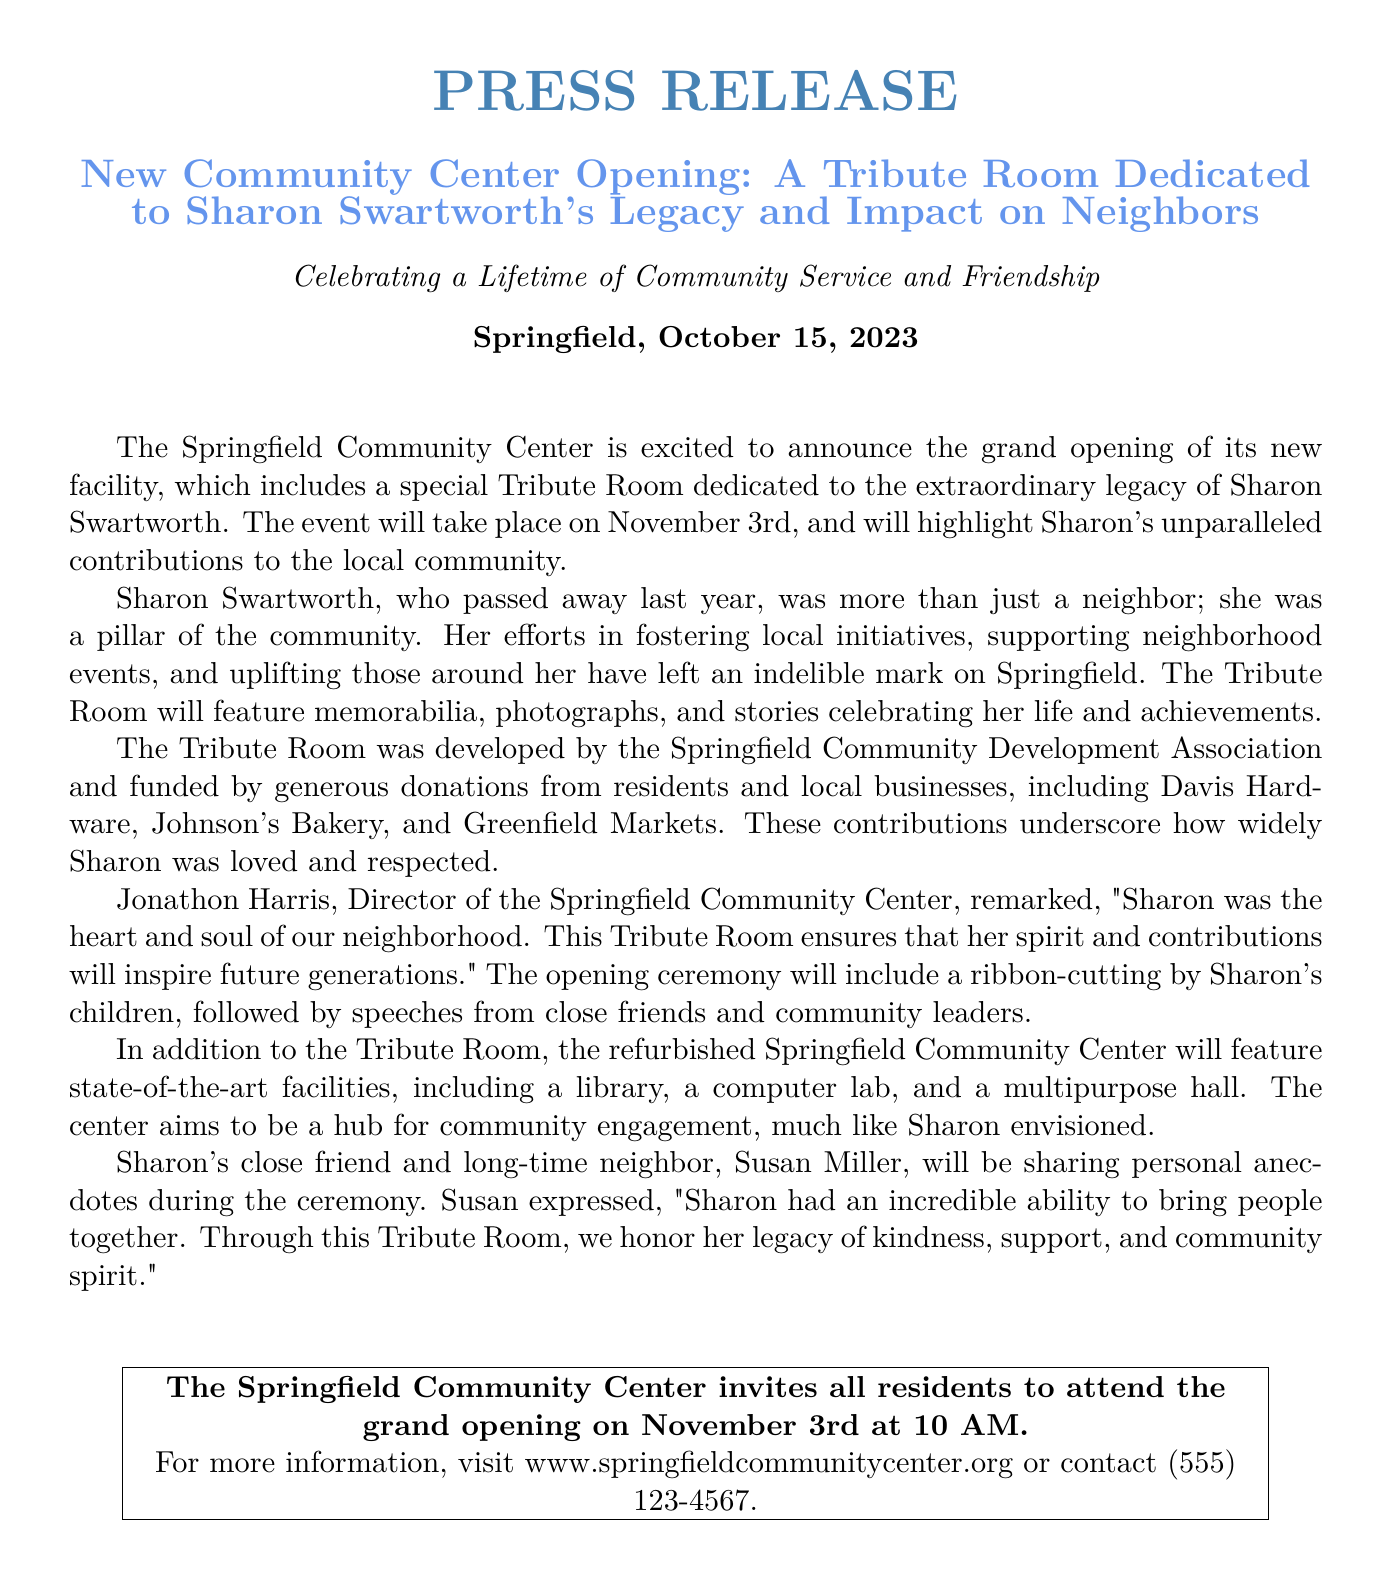What is the date of the grand opening? The grand opening is scheduled for November 3rd, as mentioned in the document.
Answer: November 3rd Who will be sharing personal anecdotes during the ceremony? The document states that Sharon's close friend, Susan Miller, will share anecdotes.
Answer: Susan Miller What is the location of the new community center? The location is specified as Springfield in the document.
Answer: Springfield Who funded the Tribute Room? The Tribute Room was funded by donations from residents and local businesses, as detailed in the document.
Answer: Donations from residents and local businesses What type of room is dedicated to Sharon Swartworth's legacy? The document specifically mentions a Tribute Room dedicated to Sharon's legacy.
Answer: Tribute Room What is Jonathon Harris's position? The document identifies Jonathon Harris as the Director of the Springfield Community Center.
Answer: Director What is emphasized as Sharon Swartworth's role in the community? The document describes Sharon as a pillar of the community, highlighting her contributions.
Answer: Pillar of the community What will the opening ceremony include? According to the document, the opening ceremony will include a ribbon-cutting and speeches.
Answer: Ribbon-cutting and speeches What kind of facilities will the refurbished community center feature? The document lists facilities such as a library, a computer lab, and a multipurpose hall.
Answer: Library, computer lab, and multipurpose hall 